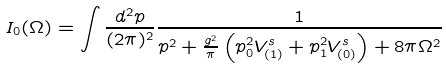Convert formula to latex. <formula><loc_0><loc_0><loc_500><loc_500>I _ { 0 } ( \Omega ) = \int \frac { d ^ { 2 } p } { ( 2 \pi ) ^ { 2 } } \frac { 1 } { p ^ { 2 } + \frac { g ^ { 2 } } { \pi } \left ( p _ { 0 } ^ { 2 } V ^ { s } _ { ( 1 ) } + p _ { 1 } ^ { 2 } V ^ { s } _ { ( 0 ) } \right ) + 8 \pi \Omega ^ { 2 } }</formula> 